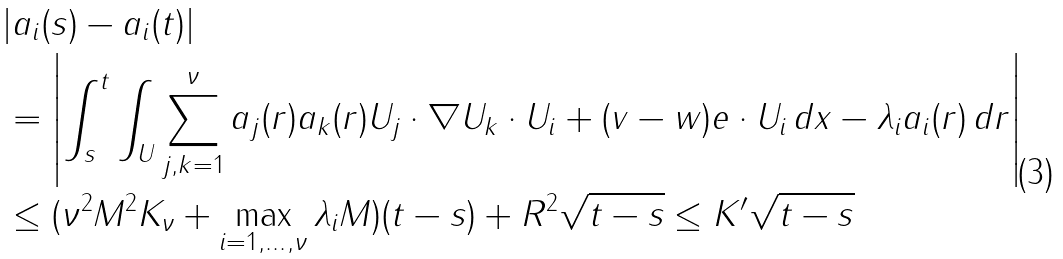<formula> <loc_0><loc_0><loc_500><loc_500>& | a _ { i } ( s ) - a _ { i } ( t ) | \\ & = \left | \int _ { s } ^ { t } \int _ { U } \sum _ { j , k = 1 } ^ { \nu } a _ { j } ( r ) a _ { k } ( r ) U _ { j } \cdot \nabla U _ { k } \cdot U _ { i } + ( v - w ) e \cdot U _ { i } \, d x - \lambda _ { i } a _ { i } ( r ) \, d r \right | \\ & \leq ( \nu ^ { 2 } M ^ { 2 } K _ { \nu } + \max _ { i = 1 , \dots , \nu } \lambda _ { i } M ) ( t - s ) + R ^ { 2 } \sqrt { t - s } \leq K ^ { \prime } \sqrt { t - s }</formula> 